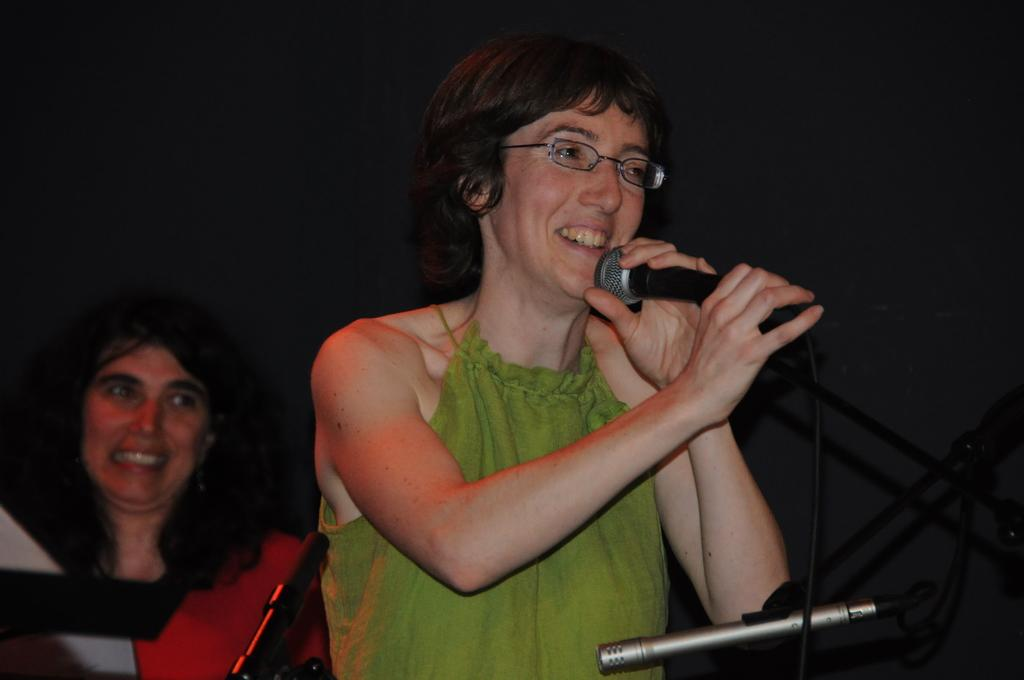What is the woman in the image holding? The woman is holding a microphone in the image. What is the facial expression of the woman holding the microphone? The woman is smiling. Are there any other people in the image? Yes, there is another woman in the image. What is the facial expression of the second woman? The second woman is also smiling. What type of chain is the woman wearing in the image? There is no chain visible on either woman in the image. How many roses can be seen in the image? There are no roses present in the image. 